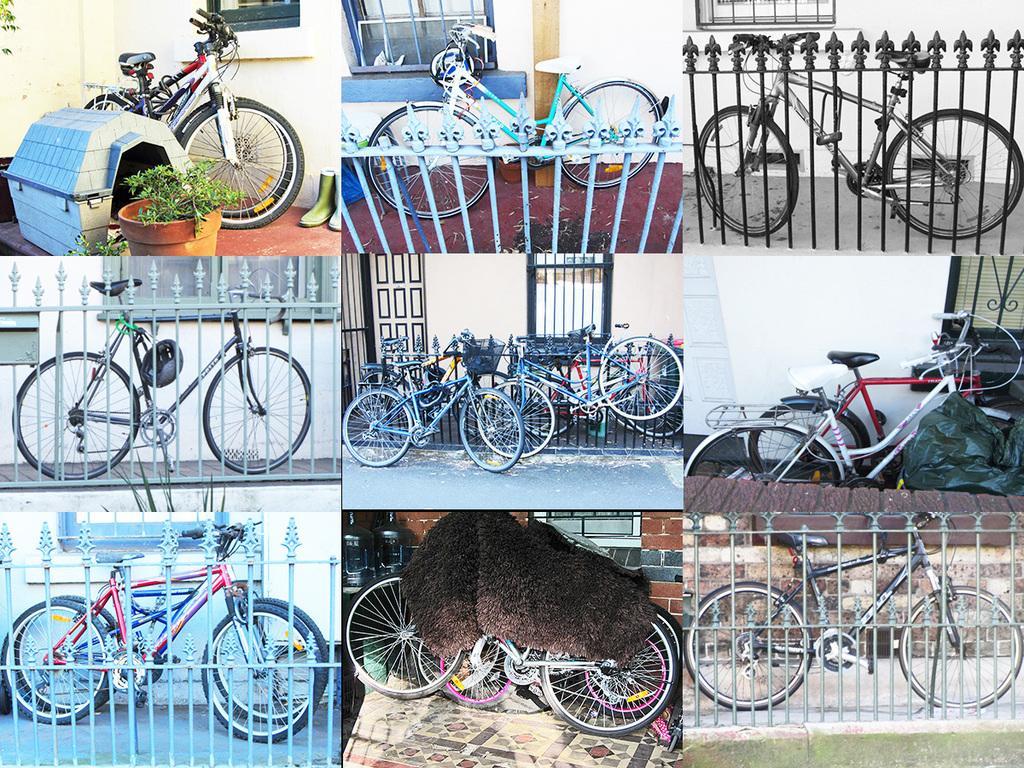Can you describe this image briefly? This looks like a collage picture. I can see the bicycles, which are parked. These are the barricades This looks like a carpet, which is kept on the bicycles. I can see the windows. This looks like a kennel. Here is a flower pot with a small plant. These are the shoes. 